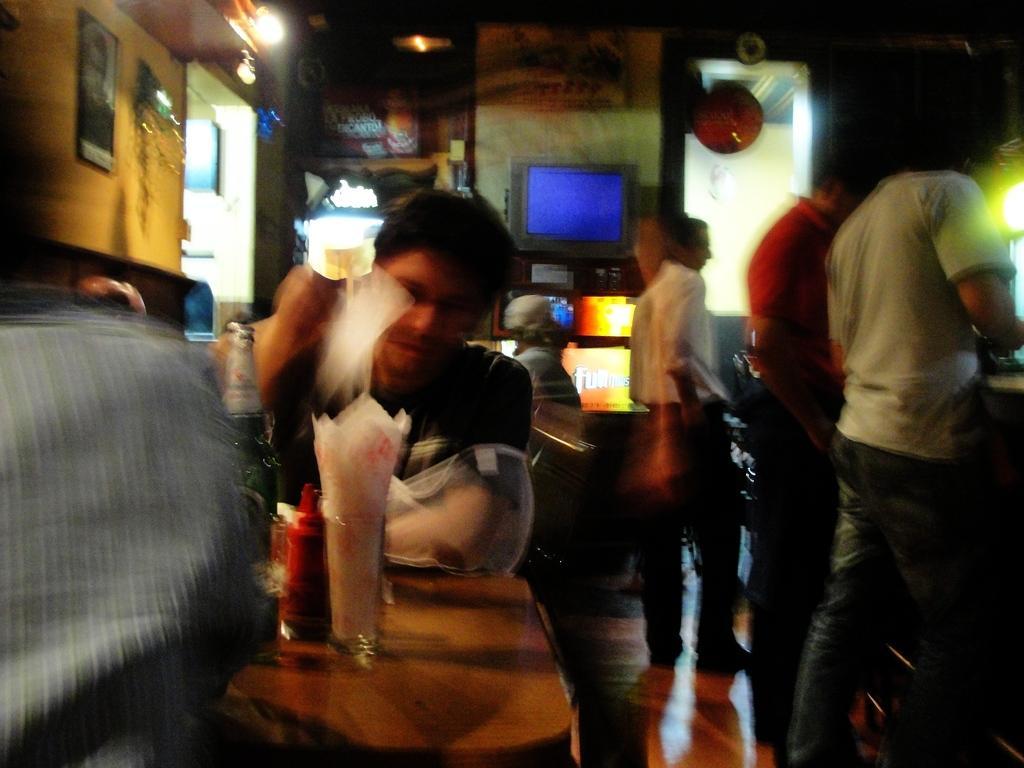Can you describe this image briefly? This image is slightly blurred, where we can see these people are sitting on the chairs near the table where bottles and glasses are kept. In the background, we can see the photo frames on the wall, the television and these people are standing. 